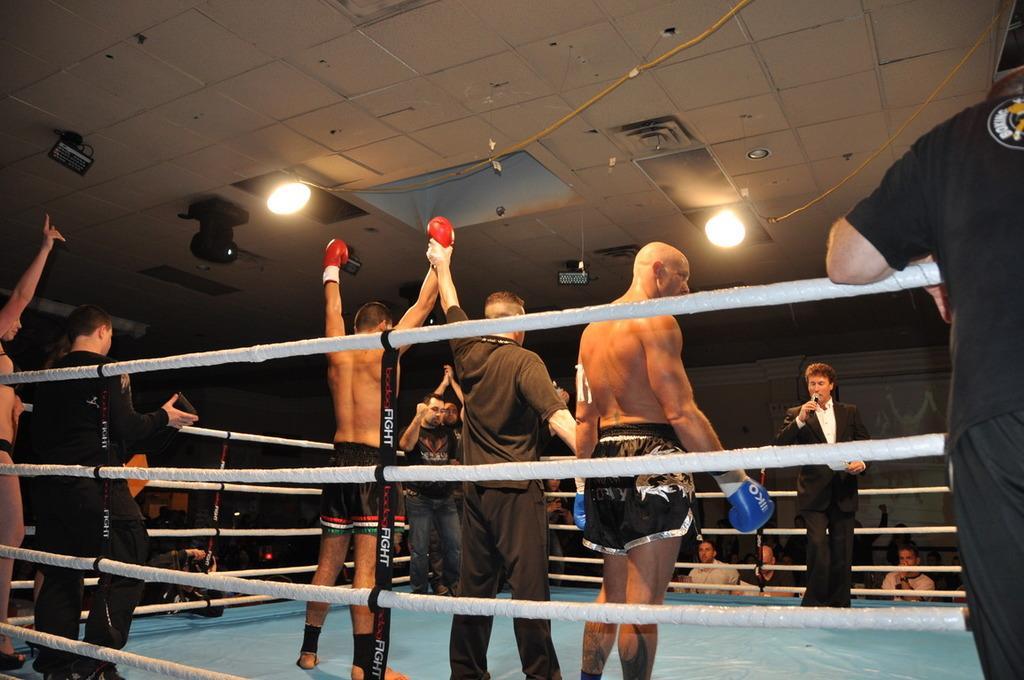How would you summarize this image in a sentence or two? In this image there are persons standing. The man in the center is standing and holding a mic in his hand wearing a black colour suit. There are ropes in the front and there are lights on the top. 